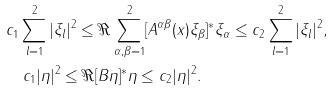Convert formula to latex. <formula><loc_0><loc_0><loc_500><loc_500>& c _ { 1 } \sum _ { l = 1 } ^ { 2 } | \xi _ { l } | ^ { 2 } \leq \Re \sum _ { \alpha , \beta = 1 } ^ { 2 } [ A ^ { \alpha \beta } ( x ) \xi _ { \beta } ] ^ { * } \xi _ { \alpha } \leq c _ { 2 } \sum _ { l = 1 } ^ { 2 } | \xi _ { l } | ^ { 2 } , \\ & \quad c _ { 1 } | \eta | ^ { 2 } \leq \Re [ B \eta ] ^ { * } \eta \leq c _ { 2 } | \eta | ^ { 2 } .</formula> 